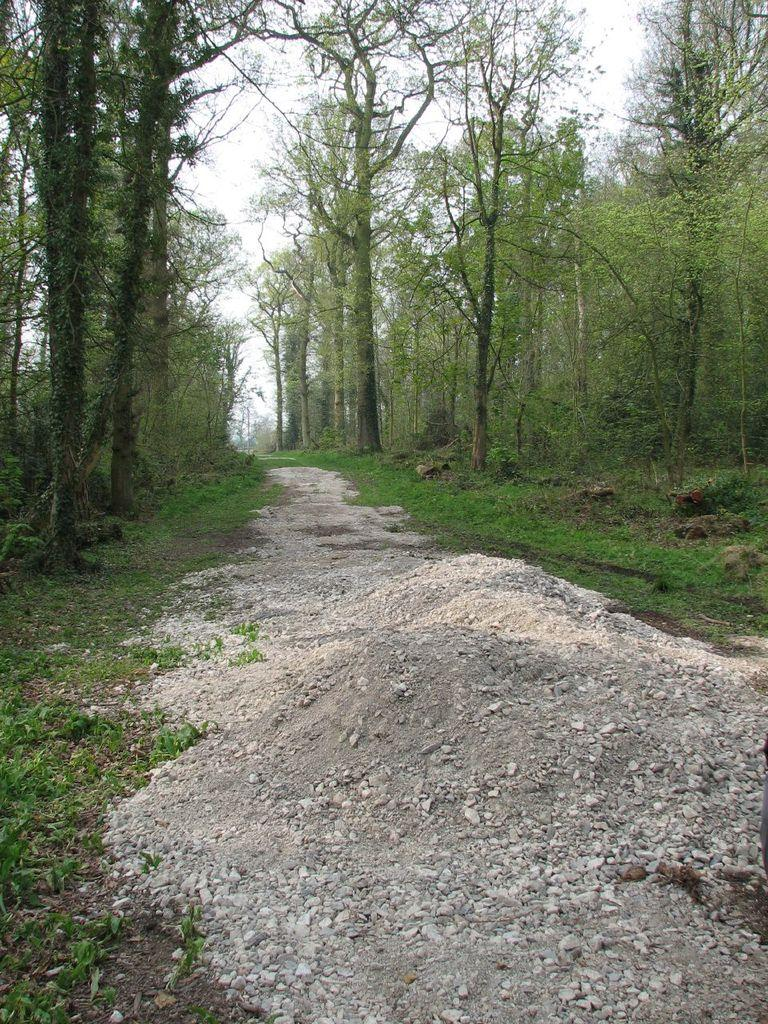What type of view is shown in the image? The image is an outside view. What can be seen at the bottom of the image? There is a road at the bottom of the image. What is present on both sides of the road? There is grass and trees on both sides of the road. What religious symbols can be seen on the road in the image? There are no religious symbols present on the road in the image. What type of authority figure can be seen in the image? There is no authority figure present in the image. 